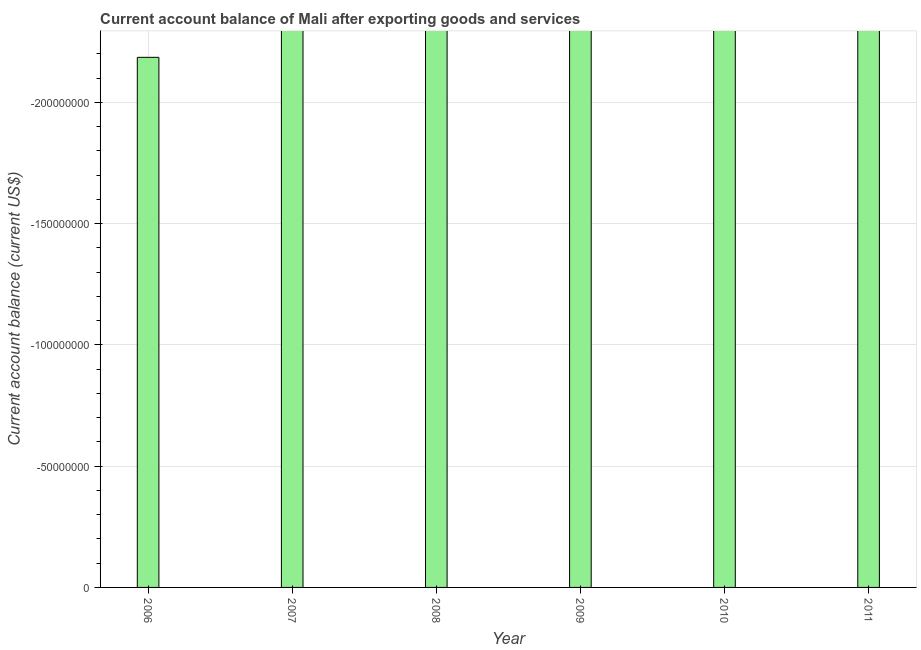Does the graph contain any zero values?
Offer a very short reply. Yes. What is the title of the graph?
Give a very brief answer. Current account balance of Mali after exporting goods and services. What is the label or title of the Y-axis?
Your response must be concise. Current account balance (current US$). What is the current account balance in 2006?
Your answer should be compact. 0. What is the sum of the current account balance?
Ensure brevity in your answer.  0. What is the average current account balance per year?
Offer a terse response. 0. In how many years, is the current account balance greater than -20000000 US$?
Offer a terse response. 0. How many years are there in the graph?
Make the answer very short. 6. What is the difference between two consecutive major ticks on the Y-axis?
Give a very brief answer. 5.00e+07. What is the Current account balance (current US$) in 2007?
Offer a terse response. 0. What is the Current account balance (current US$) of 2008?
Your answer should be compact. 0. What is the Current account balance (current US$) in 2010?
Ensure brevity in your answer.  0. What is the Current account balance (current US$) of 2011?
Your answer should be very brief. 0. 